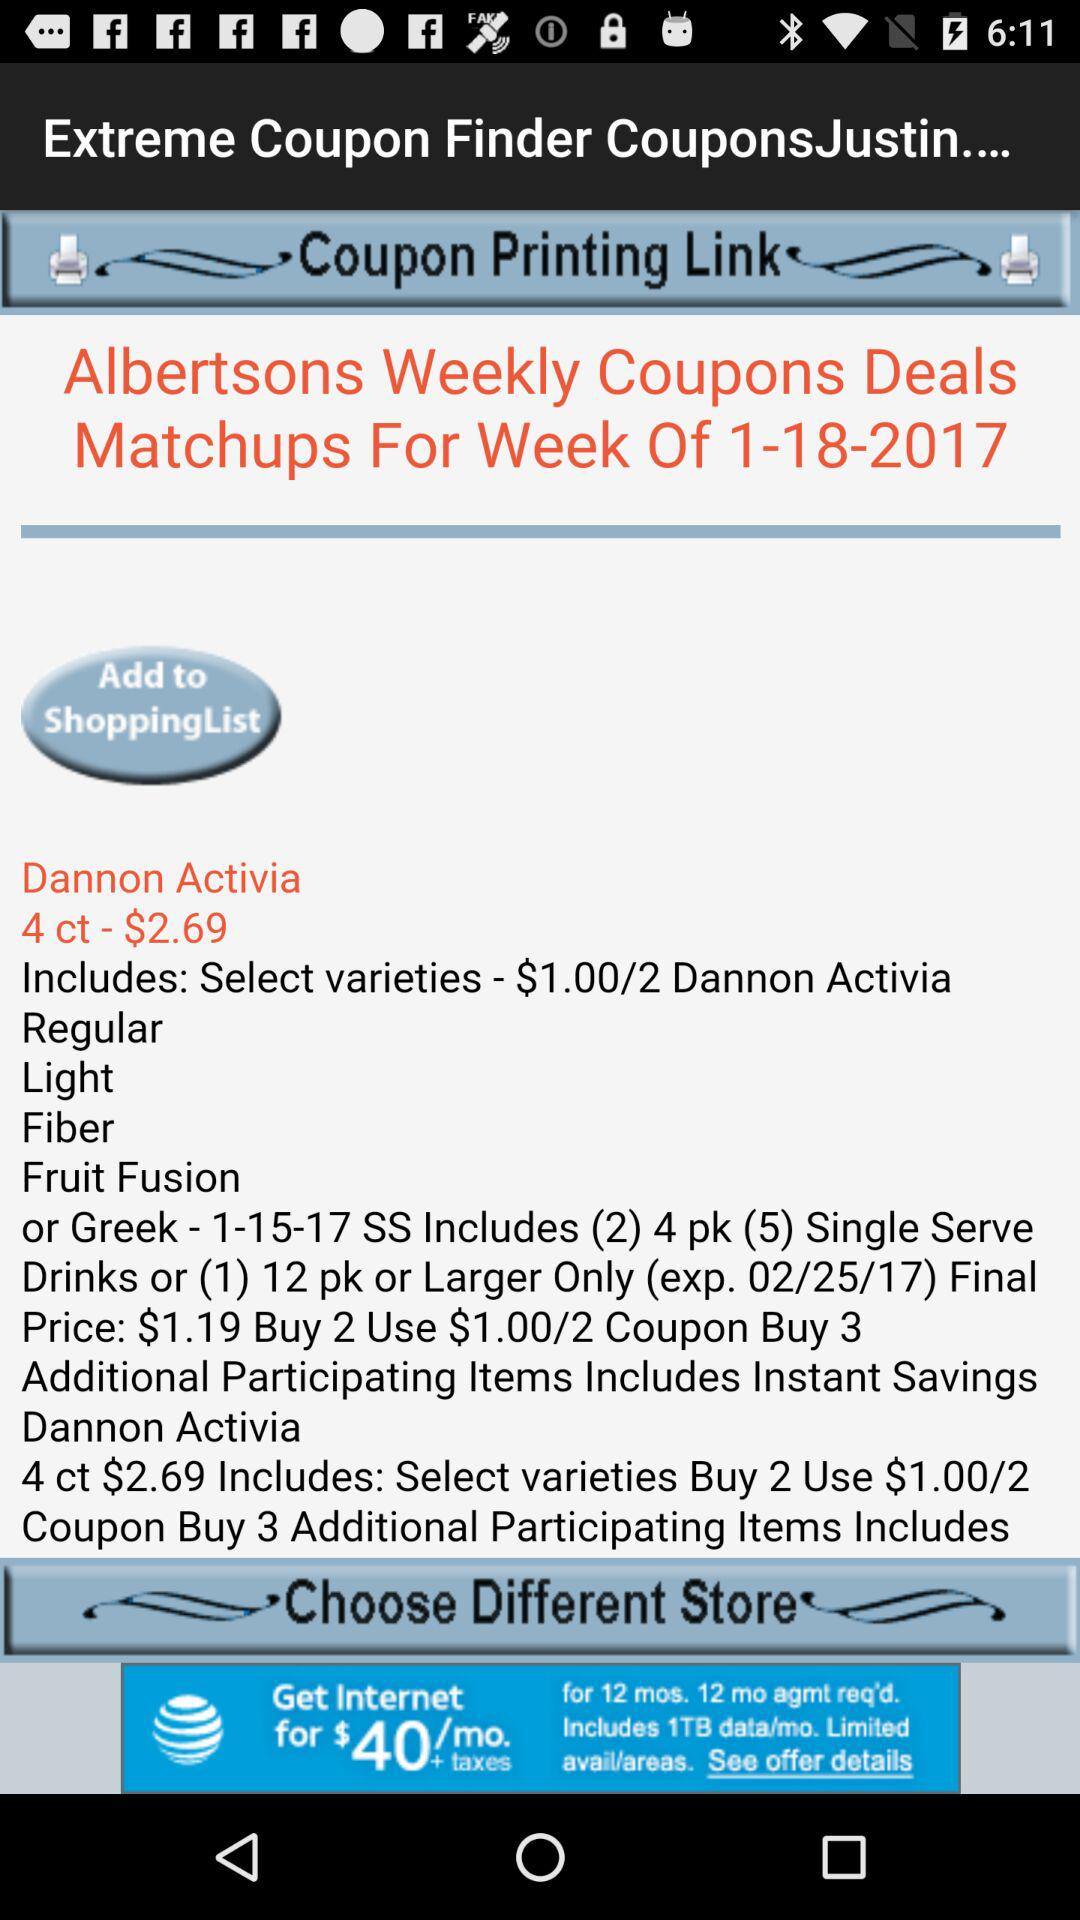Which store location is selected?
When the provided information is insufficient, respond with <no answer>. <no answer> 